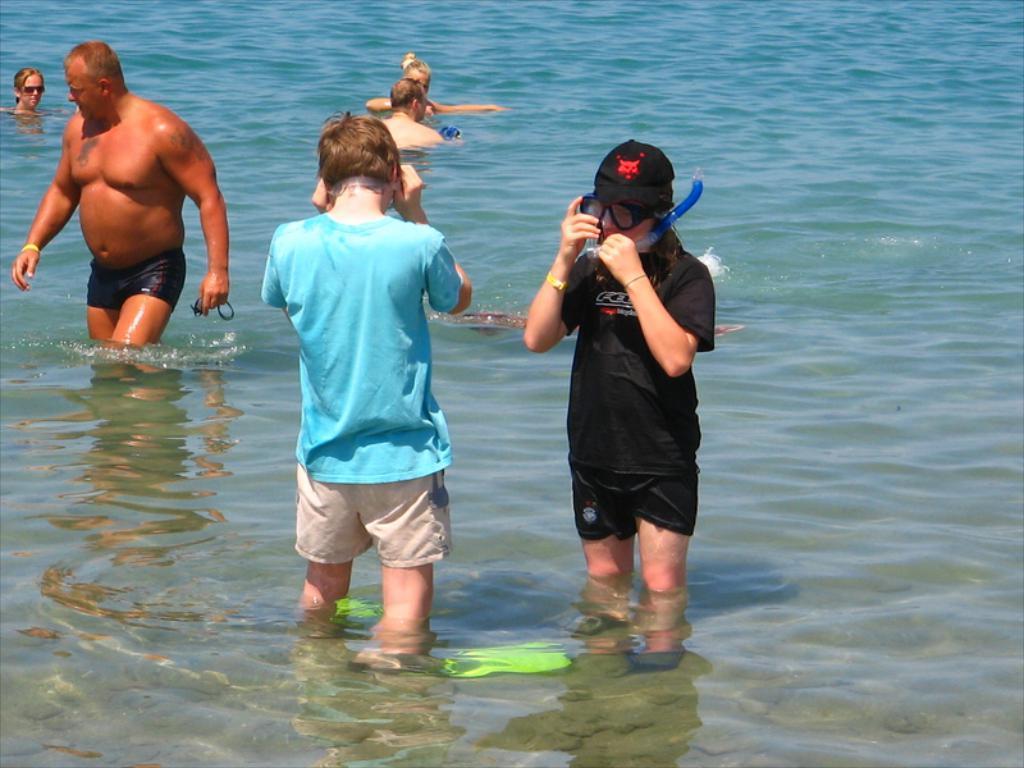Describe this image in one or two sentences. In this image there are a few people standing in the water. 